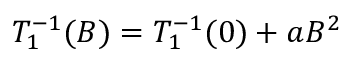<formula> <loc_0><loc_0><loc_500><loc_500>T _ { 1 } ^ { - 1 } ( B ) = T _ { 1 } ^ { - 1 } ( 0 ) + a B ^ { 2 }</formula> 